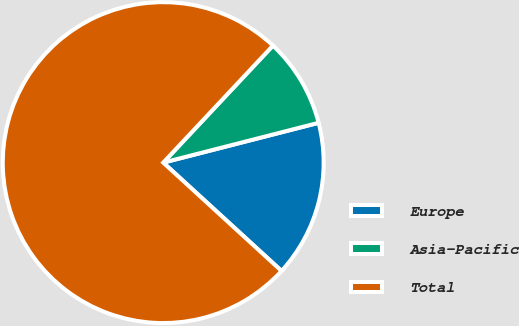<chart> <loc_0><loc_0><loc_500><loc_500><pie_chart><fcel>Europe<fcel>Asia-Pacific<fcel>Total<nl><fcel>15.79%<fcel>9.02%<fcel>75.19%<nl></chart> 